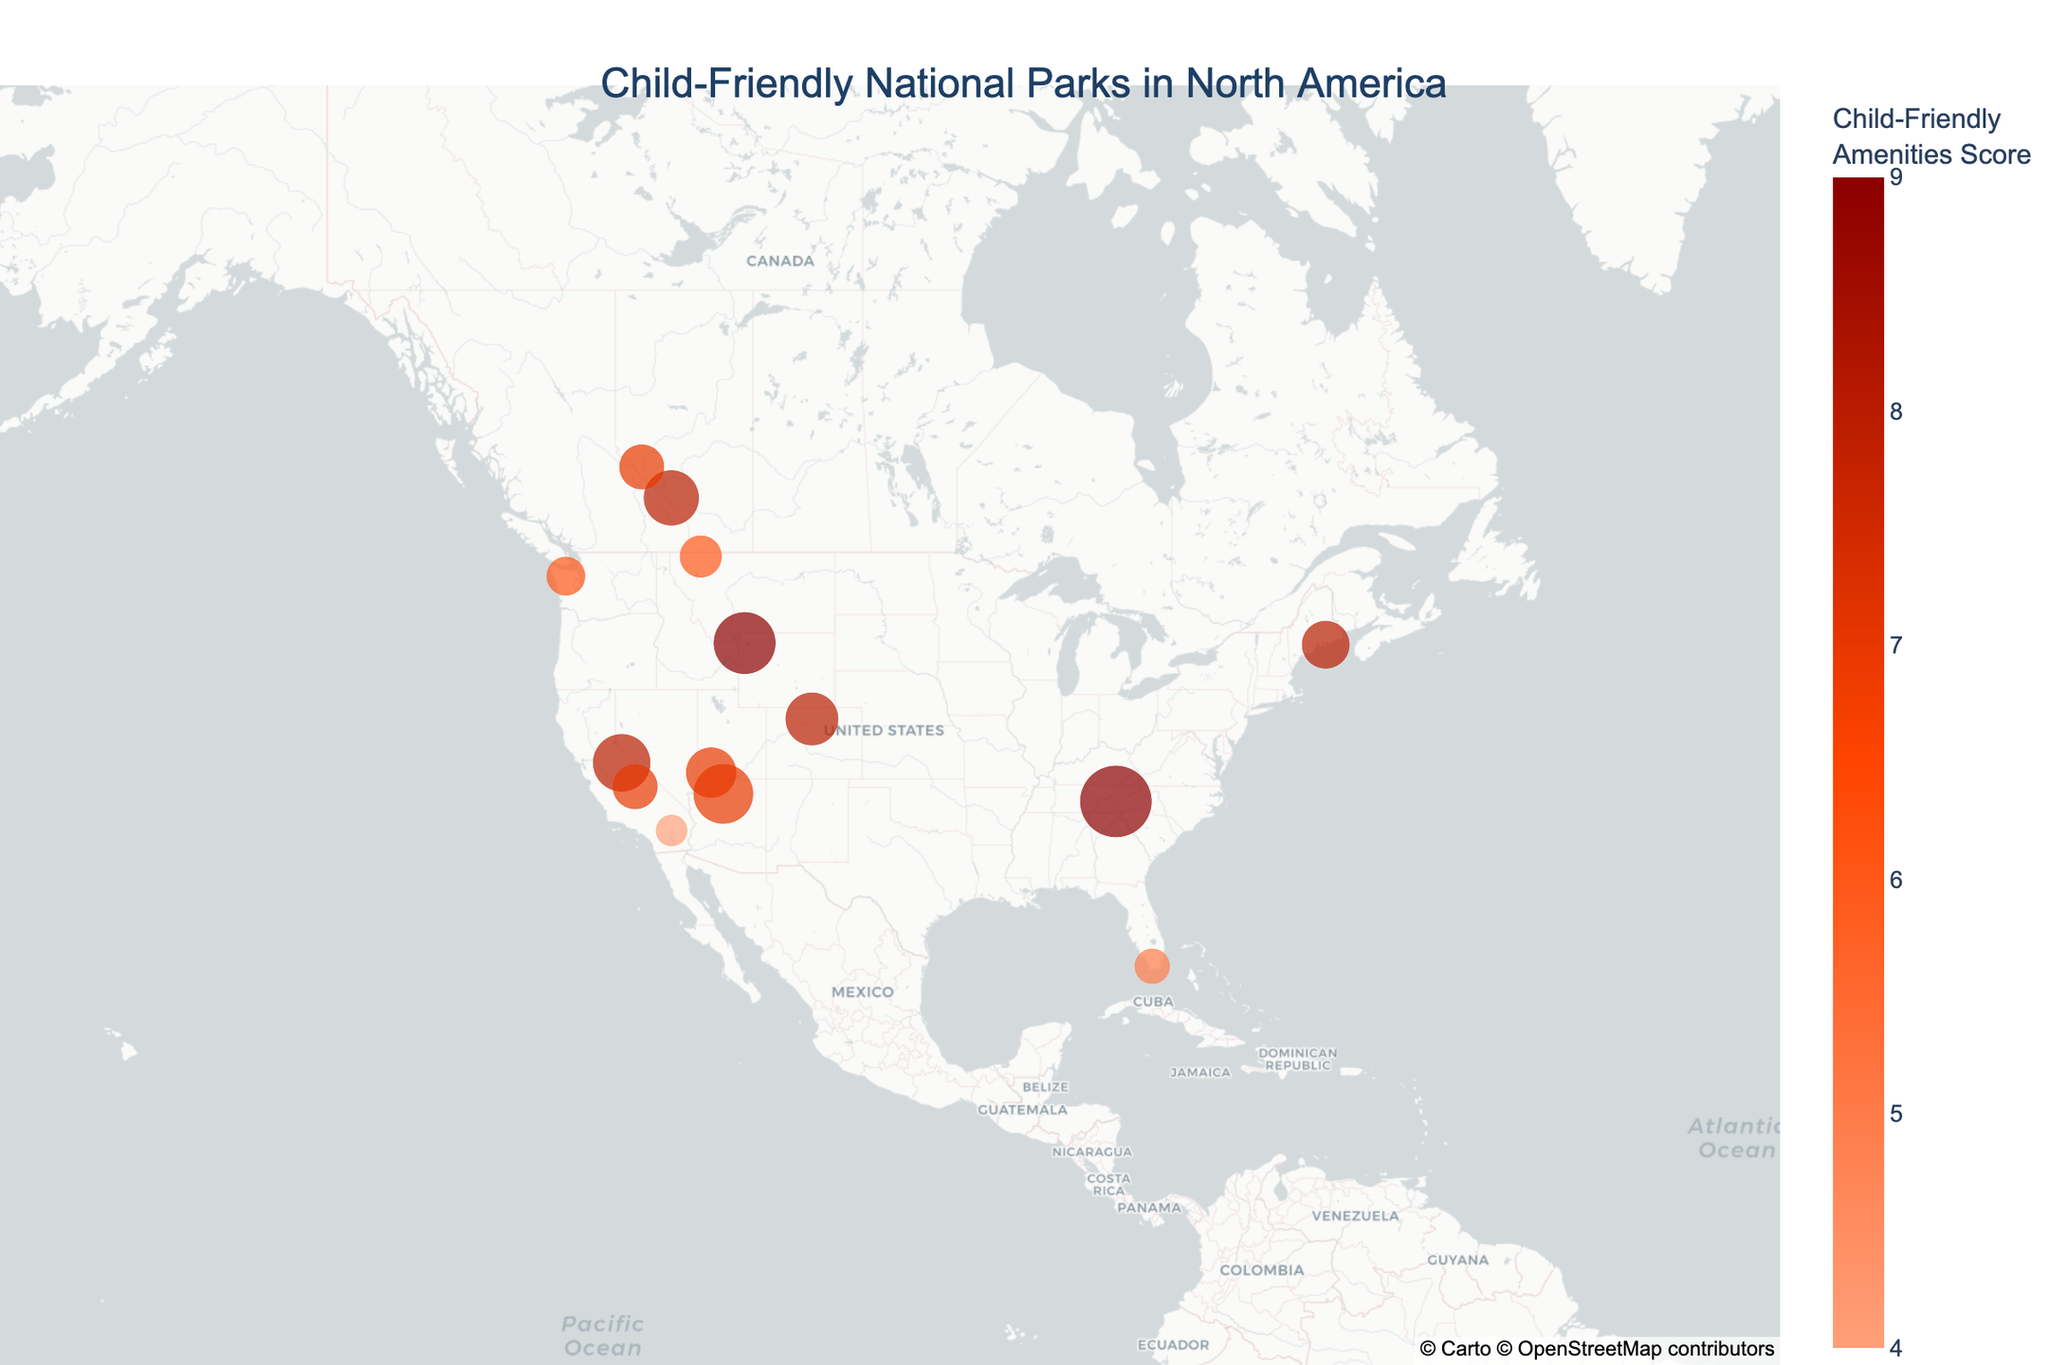How many national parks have a child-friendly amenities score of 8? There are markers or points on the map with a child-friendly amenities score of 8. By counting these markers with the specific score mentioned, we see there are 5 of them: Banff National Park, Yosemite National Park, Rocky Mountain National Park, Acadia National Park, and Rocky Mountain National Park
Answer: 5 Which national park has the highest child-friendly amenities score and the most annual family visitors? By comparing the markers on the map, Yellowstone National Park and Great Smoky Mountains National Park both have the highest score of 9. Among them, Great Smoky Mountains National Park has the highest number of annual family visitors at 2,000,000
Answer: Great Smoky Mountains National Park What's the child-friendly amenities score range in the dataset? The range of child-friendly amenities scores is determined by identifying the minimum and maximum scores represented on the color bar. The minimum score is 4 (Joshua Tree National Park) and the maximum score is 9. So, the range is from 4 to 9
Answer: 4 to 9 Which national park is in the southernmost position on the map? To find the southernmost park, we need to look at the latitudes and identify the lowest one. The lowest latitude point is Everglades National Park at approximately 25.2866
Answer: Everglades National Park What is the average annual family visitors for the national parks with a child-friendly amenities score less than 6? Parks with a score < 6 are Everglades National Park and Joshua Tree National Park. Adding their number of annual family visitors gives 500,000 + 400,000 = 900,000 visitors. Dividing by 2 (as there are 2 parks) gives an average of 450,000
Answer: 450,000 Which park located in Canada is visualized on the map, and how many annual family visitors does it attract? Banff National Park and Jasper National Park are located in Canada. By looking at the respective size of the markers and their tooltips, Banff attracts 1,200,000 and Jasper attracts 800,000
Answer: 1,200,000 and 800,000 What is the difference in child-friendly amenities scores between Glacier National Park and Zion National Park? Glacier National Park has a score of 6 and Zion National Park has a score of 7. The difference is calculated by 7 - 6
Answer: 1 